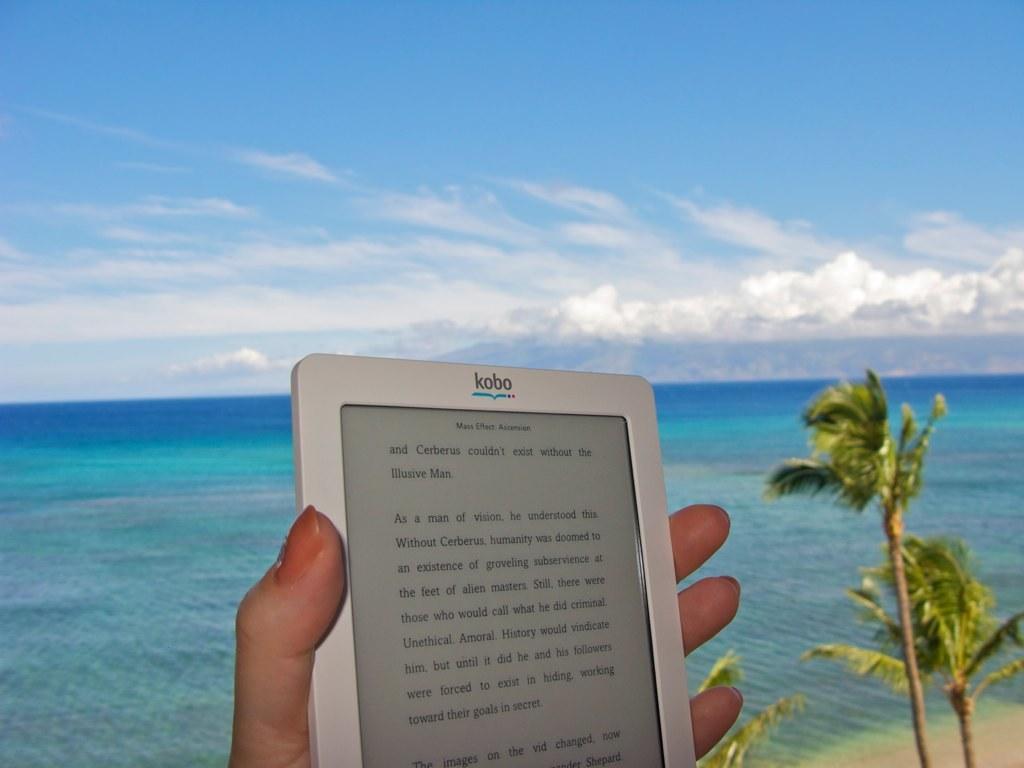In one or two sentences, can you explain what this image depicts? In the image we can see there is a person holding tablet in her hand. Behind there are trees and there is an ocean. 